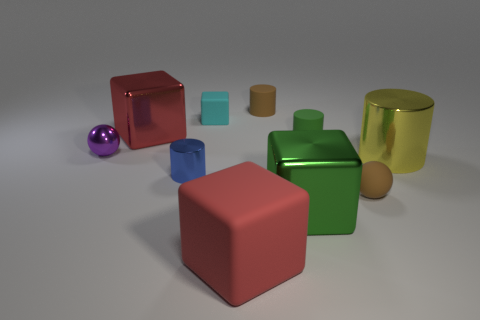Subtract all large yellow metal cylinders. How many cylinders are left? 3 Subtract all blue spheres. How many red cubes are left? 2 Subtract all red blocks. How many blocks are left? 2 Subtract all cylinders. How many objects are left? 6 Subtract 3 cylinders. How many cylinders are left? 1 Add 6 small metal cylinders. How many small metal cylinders exist? 7 Subtract 0 yellow cubes. How many objects are left? 10 Subtract all gray balls. Subtract all gray cylinders. How many balls are left? 2 Subtract all large purple rubber balls. Subtract all small green matte objects. How many objects are left? 9 Add 9 tiny blue cylinders. How many tiny blue cylinders are left? 10 